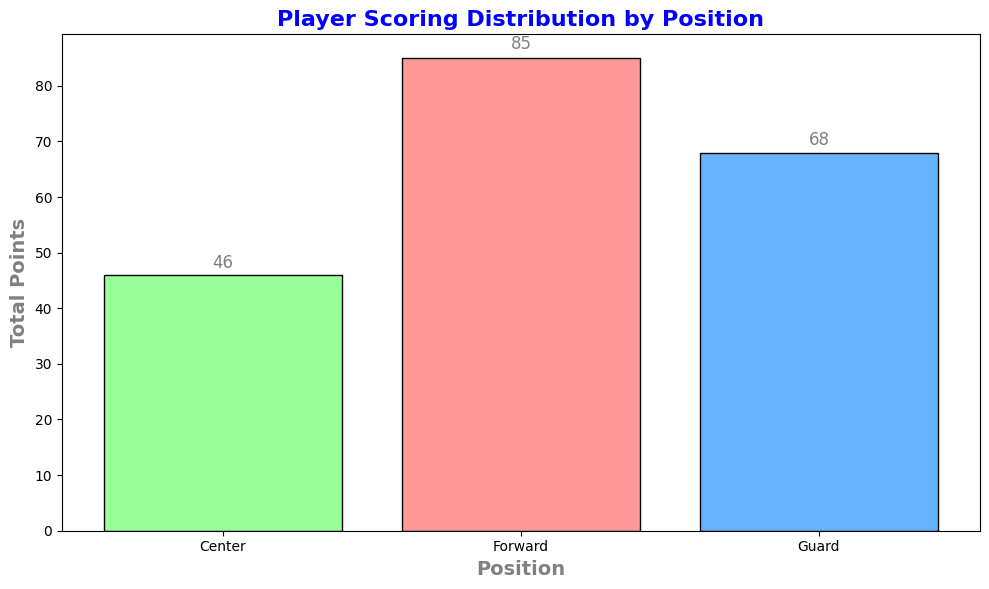What's the total number of points scored by Forwards? To find the total points scored by Forwards, look at the bar labeled "Forward" and read the height of the bar, which shows the sum of the points scored by all Forward players.
Answer: 85 Which position scored the most points? To determine which position scored the most points, compare the heights of the bars for each position. The position with the highest bar represents the one that scored the most points.
Answer: Forward How many points more did Forwards score compared to Centers? Find the total points for Forwards and Centers by looking at the heights of their respective bars, then subtract the total points of Centers from that of Forwards. Forwards scored 85 points and Centers scored 46 points, so 85 - 46 = 39.
Answer: 39 What is the average number of points scored by Guards? Find the total points scored by Guards from the height of the bar (68 points), then divide by the number of Guard players (4). So, the average is 68 / 4 = 17.
Answer: 17 How do the total points scored by Guards compare to those scored by Centers? Compare the height of the bars for Guards and Centers. The bar height for Guards (68) is greater than that for Centers (46).
Answer: Guards scored more Which bar represents the data for the Centers? Identify the bar that is colored green, as each position is assigned a specific color. The green bar represents the data for Centers.
Answer: Green bar What is the sum of points scored by Players in both Guard and Center positions? Add the total points scored by Guards (68) to the total points scored by Centers (46). So, 68 + 46 = 114.
Answer: 114 Which position has the shortest bar, and what does it represent? The shortest bar on the plot is the green bar, representing the Center position with the least total points scored.
Answer: Center How much more points did Forwards score than Guards? Find the total points scored by Forwards (85) and Guards (68). Subtract the total points of Guards from that of Forwards: 85 - 68 = 17.
Answer: 17 What color represents the total points scored by Guards? Observe the color used for the bar representing Guards, which is blue.
Answer: Blue 